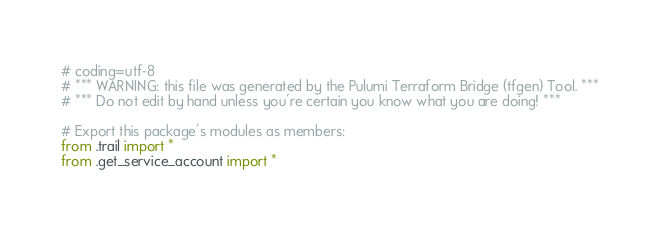<code> <loc_0><loc_0><loc_500><loc_500><_Python_># coding=utf-8
# *** WARNING: this file was generated by the Pulumi Terraform Bridge (tfgen) Tool. ***
# *** Do not edit by hand unless you're certain you know what you are doing! ***

# Export this package's modules as members:
from .trail import *
from .get_service_account import *
</code> 